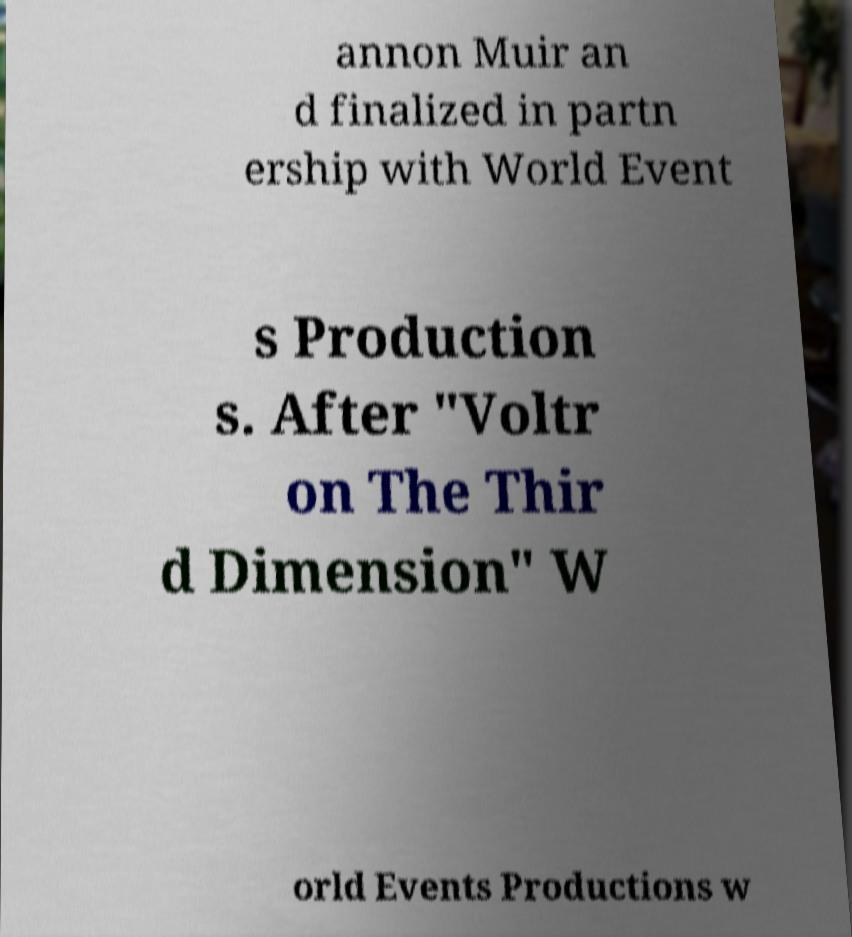There's text embedded in this image that I need extracted. Can you transcribe it verbatim? annon Muir an d finalized in partn ership with World Event s Production s. After "Voltr on The Thir d Dimension" W orld Events Productions w 